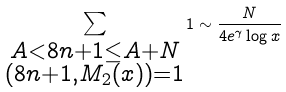<formula> <loc_0><loc_0><loc_500><loc_500>\sum _ { \substack { A < 8 n + 1 \leq A + N \\ ( 8 n + 1 , M _ { 2 } ( x ) ) = 1 } } 1 \sim \frac { N } { 4 e ^ { \gamma } \log x }</formula> 